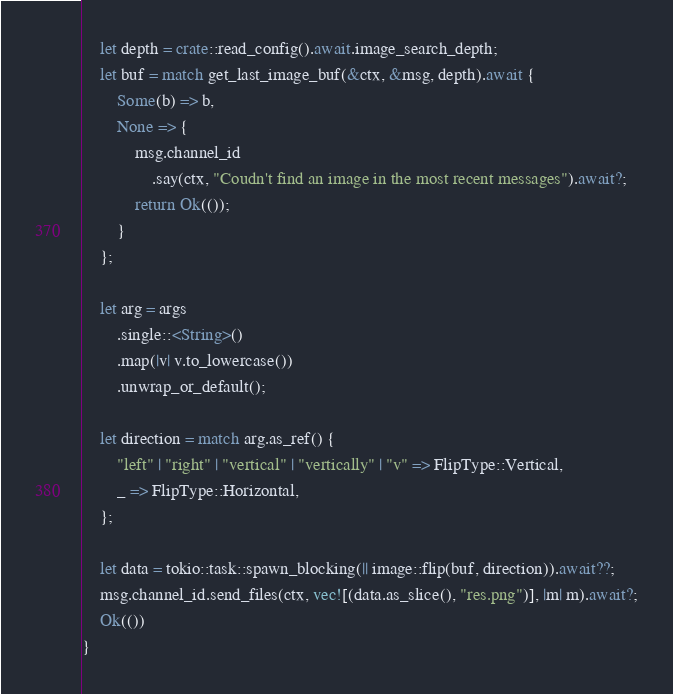<code> <loc_0><loc_0><loc_500><loc_500><_Rust_>    let depth = crate::read_config().await.image_search_depth;
    let buf = match get_last_image_buf(&ctx, &msg, depth).await {
        Some(b) => b,
        None => {
            msg.channel_id
                .say(ctx, "Coudn't find an image in the most recent messages").await?;
            return Ok(());
        }
    };

    let arg = args
        .single::<String>()
        .map(|v| v.to_lowercase())
        .unwrap_or_default();

    let direction = match arg.as_ref() {
        "left" | "right" | "vertical" | "vertically" | "v" => FlipType::Vertical,
        _ => FlipType::Horizontal,
    };

    let data = tokio::task::spawn_blocking(|| image::flip(buf, direction)).await??;
    msg.channel_id.send_files(ctx, vec![(data.as_slice(), "res.png")], |m| m).await?;
    Ok(())
}
</code> 